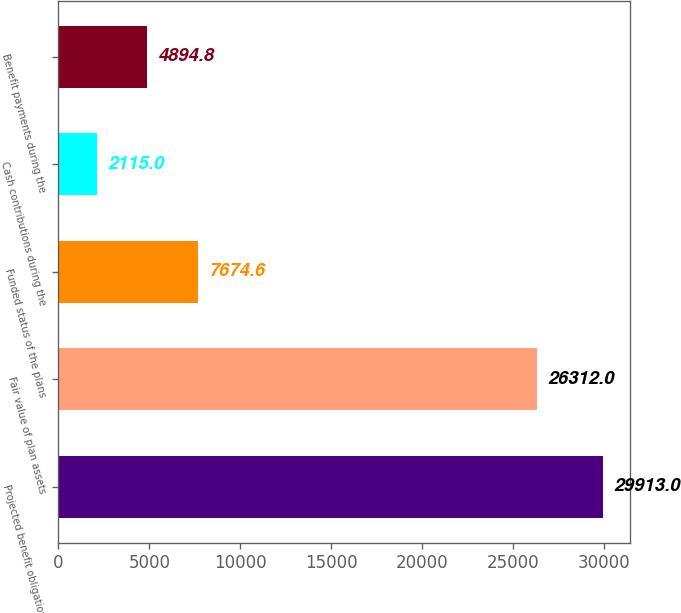Convert chart to OTSL. <chart><loc_0><loc_0><loc_500><loc_500><bar_chart><fcel>Projected benefit obligation<fcel>Fair value of plan assets<fcel>Funded status of the plans<fcel>Cash contributions during the<fcel>Benefit payments during the<nl><fcel>29913<fcel>26312<fcel>7674.6<fcel>2115<fcel>4894.8<nl></chart> 